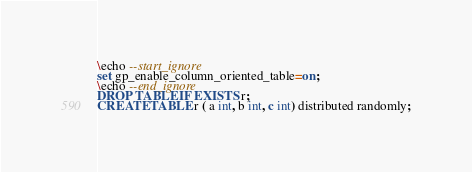Convert code to text. <code><loc_0><loc_0><loc_500><loc_500><_SQL_>\echo --start_ignore
set gp_enable_column_oriented_table=on;
\echo --end_ignore
DROP TABLE IF EXISTS r;
CREATE TABLE r ( a int, b int, c int) distributed randomly;
</code> 